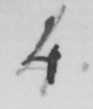Please provide the text content of this handwritten line. 4 . 